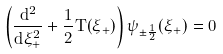<formula> <loc_0><loc_0><loc_500><loc_500>\left ( \frac { d ^ { 2 } } { d \xi ^ { 2 } _ { + } } + \frac { 1 } { 2 } T ( \xi _ { + } ) \right ) \psi _ { \pm \frac { 1 } { 2 } } ( \xi _ { + } ) = 0</formula> 